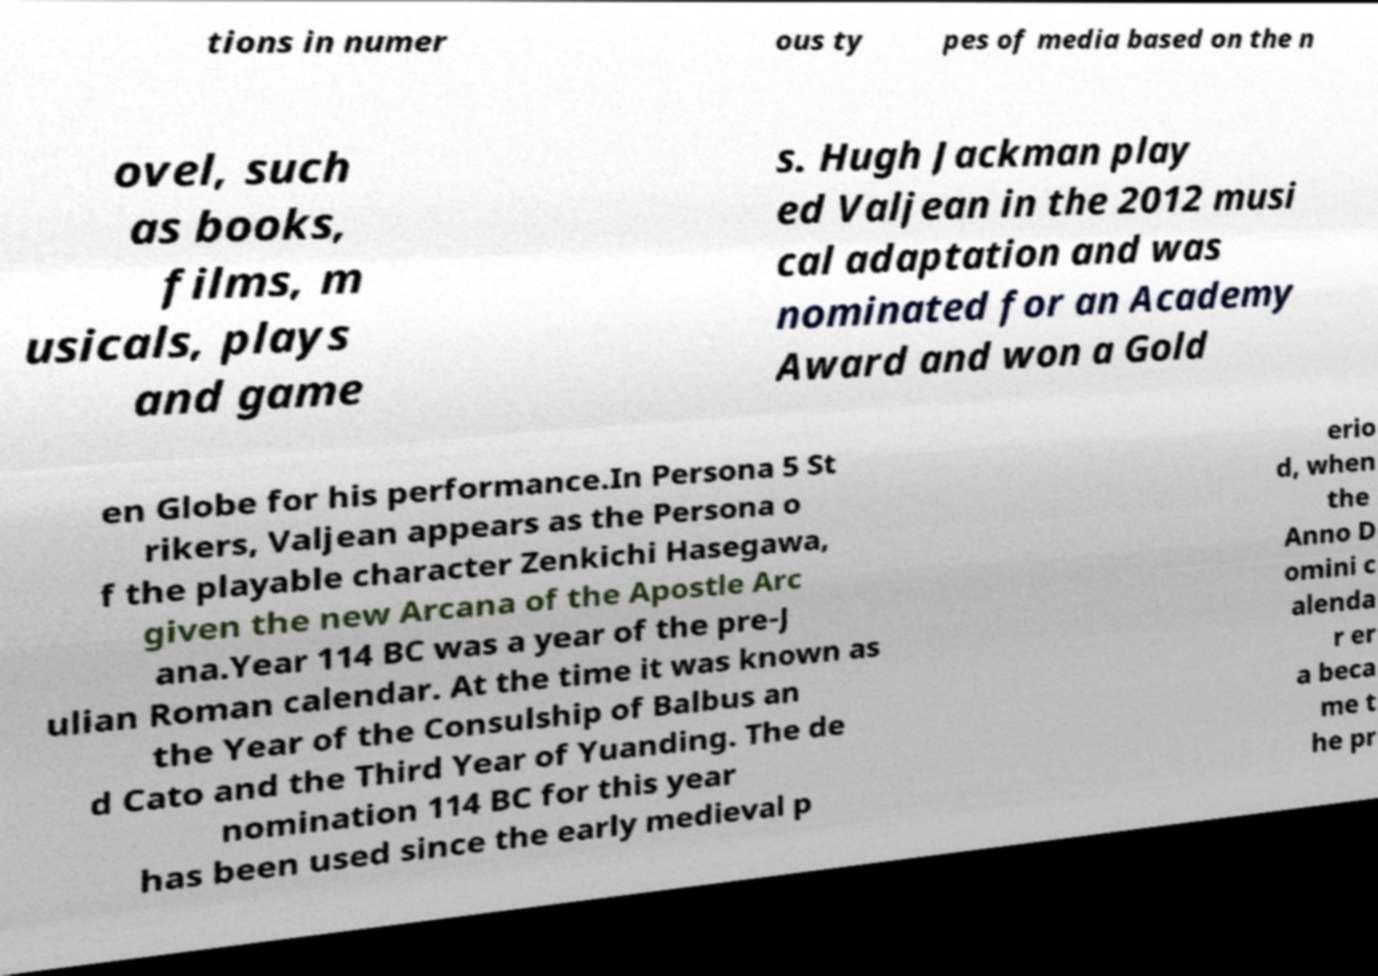Could you extract and type out the text from this image? tions in numer ous ty pes of media based on the n ovel, such as books, films, m usicals, plays and game s. Hugh Jackman play ed Valjean in the 2012 musi cal adaptation and was nominated for an Academy Award and won a Gold en Globe for his performance.In Persona 5 St rikers, Valjean appears as the Persona o f the playable character Zenkichi Hasegawa, given the new Arcana of the Apostle Arc ana.Year 114 BC was a year of the pre-J ulian Roman calendar. At the time it was known as the Year of the Consulship of Balbus an d Cato and the Third Year of Yuanding. The de nomination 114 BC for this year has been used since the early medieval p erio d, when the Anno D omini c alenda r er a beca me t he pr 